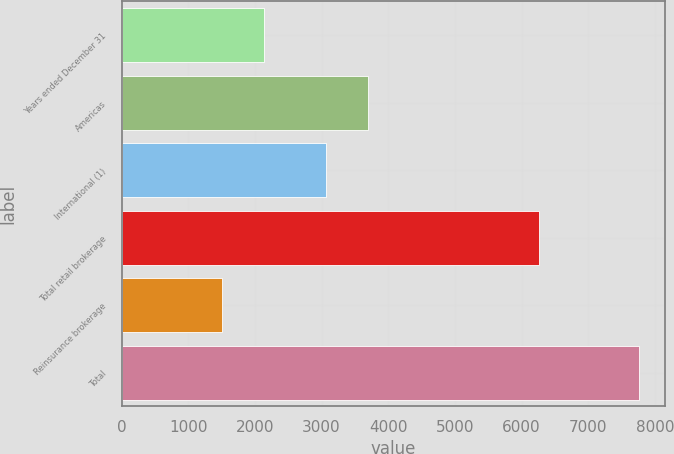<chart> <loc_0><loc_0><loc_500><loc_500><bar_chart><fcel>Years ended December 31<fcel>Americas<fcel>International (1)<fcel>Total retail brokerage<fcel>Reinsurance brokerage<fcel>Total<nl><fcel>2130.6<fcel>3690.6<fcel>3065<fcel>6256<fcel>1505<fcel>7761<nl></chart> 